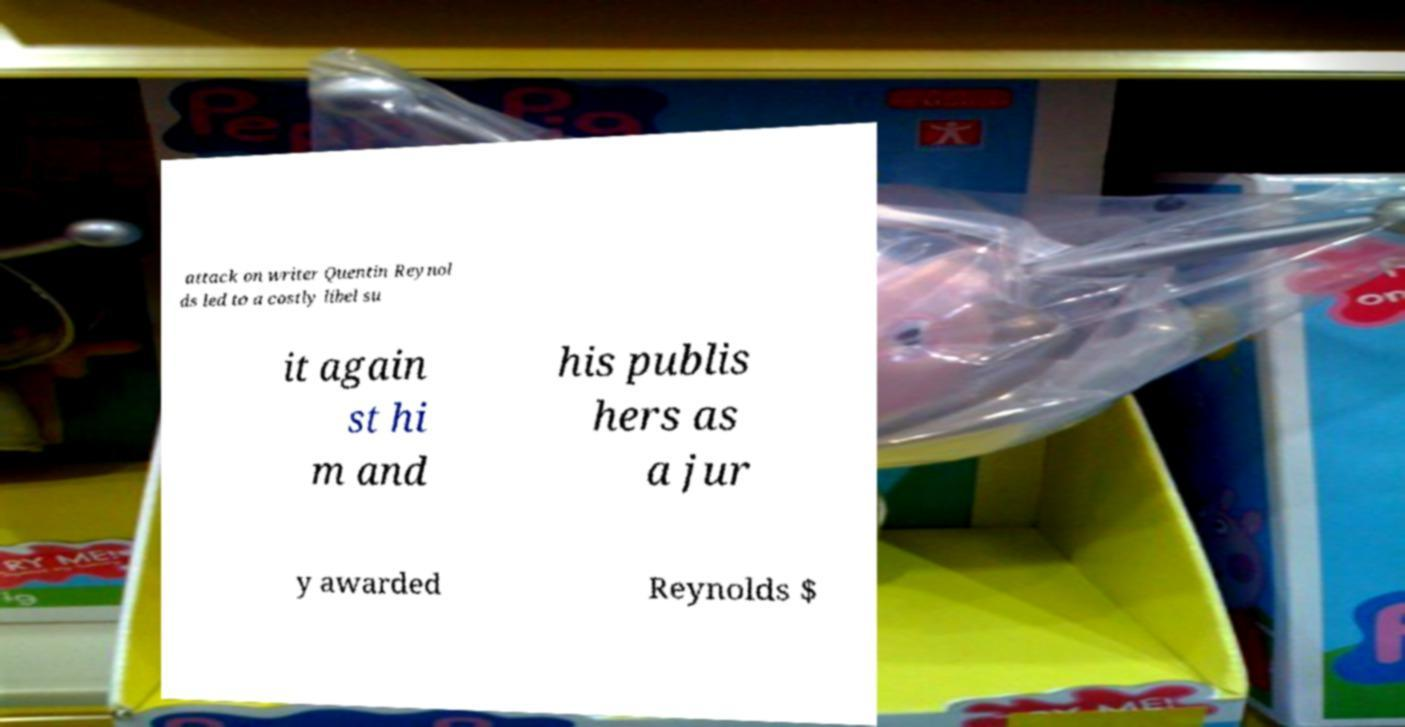I need the written content from this picture converted into text. Can you do that? attack on writer Quentin Reynol ds led to a costly libel su it again st hi m and his publis hers as a jur y awarded Reynolds $ 